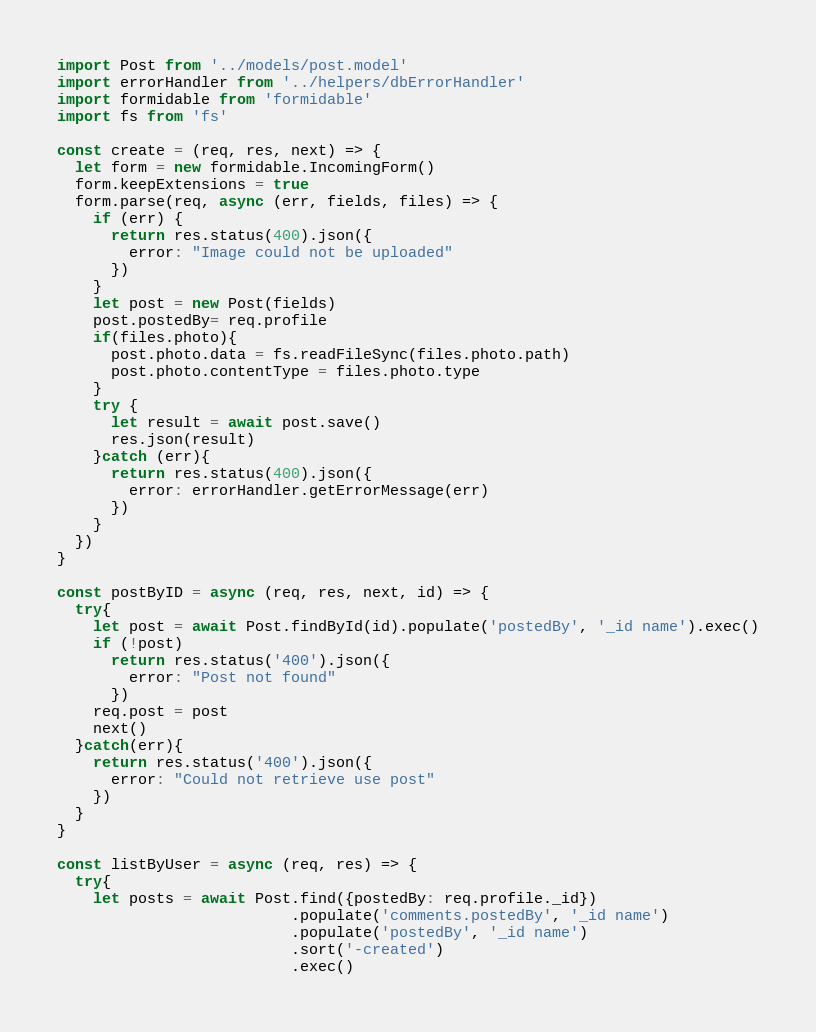Convert code to text. <code><loc_0><loc_0><loc_500><loc_500><_JavaScript_>import Post from '../models/post.model'
import errorHandler from '../helpers/dbErrorHandler'
import formidable from 'formidable'
import fs from 'fs'

const create = (req, res, next) => {
  let form = new formidable.IncomingForm()
  form.keepExtensions = true
  form.parse(req, async (err, fields, files) => {
    if (err) {
      return res.status(400).json({
        error: "Image could not be uploaded"
      })
    }
    let post = new Post(fields)
    post.postedBy= req.profile
    if(files.photo){
      post.photo.data = fs.readFileSync(files.photo.path)
      post.photo.contentType = files.photo.type
    }
    try {
      let result = await post.save()
      res.json(result)
    }catch (err){
      return res.status(400).json({
        error: errorHandler.getErrorMessage(err)
      })
    }
  })
}

const postByID = async (req, res, next, id) => {
  try{
    let post = await Post.findById(id).populate('postedBy', '_id name').exec()
    if (!post)
      return res.status('400').json({
        error: "Post not found"
      })
    req.post = post
    next()
  }catch(err){
    return res.status('400').json({
      error: "Could not retrieve use post"
    })
  }
}

const listByUser = async (req, res) => {
  try{
    let posts = await Post.find({postedBy: req.profile._id})
                          .populate('comments.postedBy', '_id name')
                          .populate('postedBy', '_id name')
                          .sort('-created')
                          .exec()</code> 